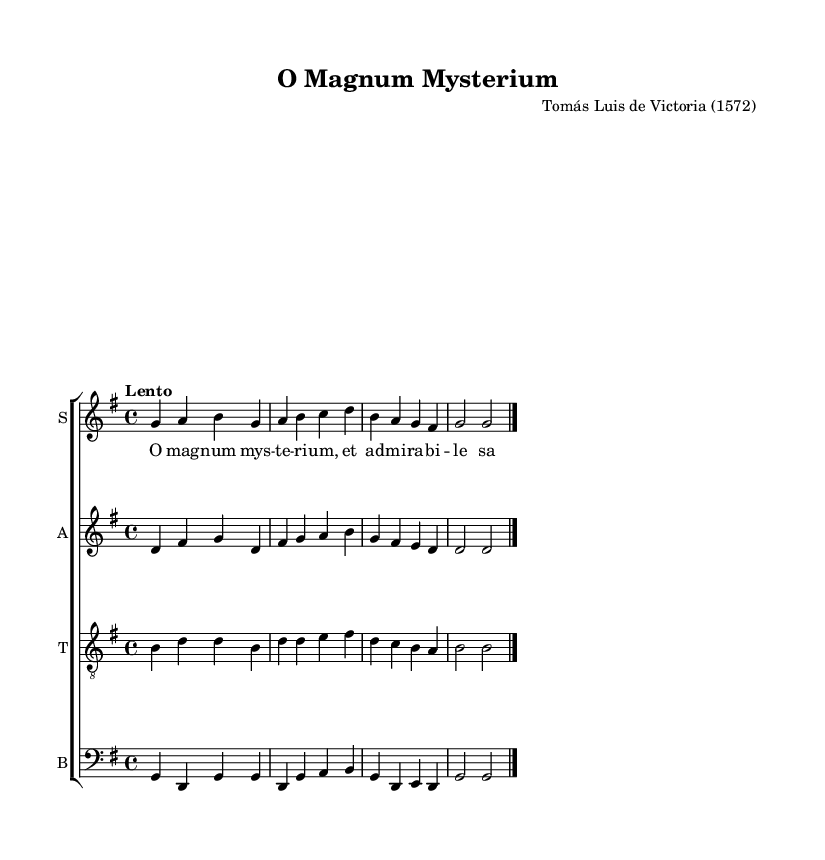What is the title of this piece? The title is prominently displayed at the beginning of the sheet music, labeled as "O Magnum Mysterium."
Answer: O Magnum Mysterium Who is the composer of this piece? The composer's name is indicated below the title in the header section, which states "Tomás Luis de Victoria (1572)."
Answer: Tomás Luis de Victoria What is the key signature of this music? The key signature can be identified in the beginning of the sheet music, where it is indicated as "g" with one sharp, indicating G major.
Answer: G major What is the time signature of this piece? The time signature is shown at the beginning of the piece as "4/4," indicating a common time with four beats per measure.
Answer: 4/4 What is the tempo marking of this composition? The tempo is given as "Lento," which means slow, and is located directly after the time signature in the global setting.
Answer: Lento How many musical voices are present in this score? By examining the score layout, I see four distinct voices: soprano, alto, tenor, and bass, each corresponding to a different staff.
Answer: Four What is the first lyric line in the soprano part? The first lyric line under the soprano part starts with "O mag" and continues with the rest of the verse. It can be found written underneath the soprano voice.
Answer: O mag 